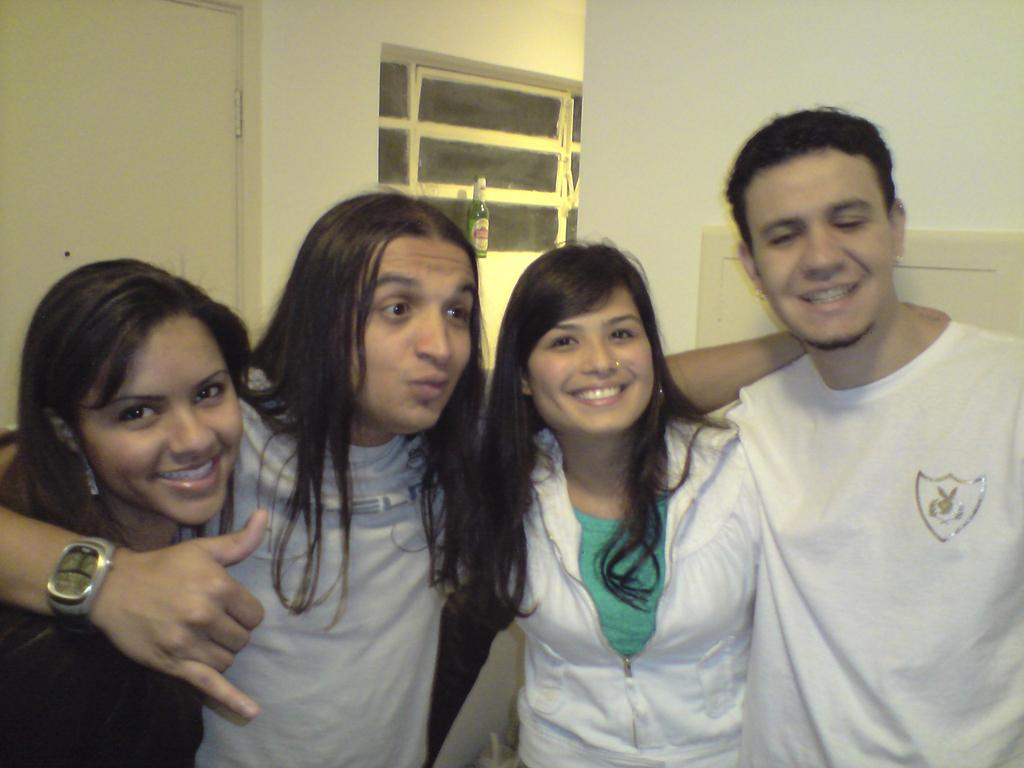What is happening with the people in the room? The people in the room are standing and smiling. What can be used for entering or exiting the room? There is a door in the room for entering or exiting. What can be used for allowing natural light and fresh air into the room? There is a window in the room for allowing natural light and fresh air. What is placed on the wall in the room? There is a bottle on the wall in the room. What type of flowers can be seen growing near the window in the image? There are no flowers visible in the image; it only shows people standing and smiling, a door, a window, and a bottle on the wall. 